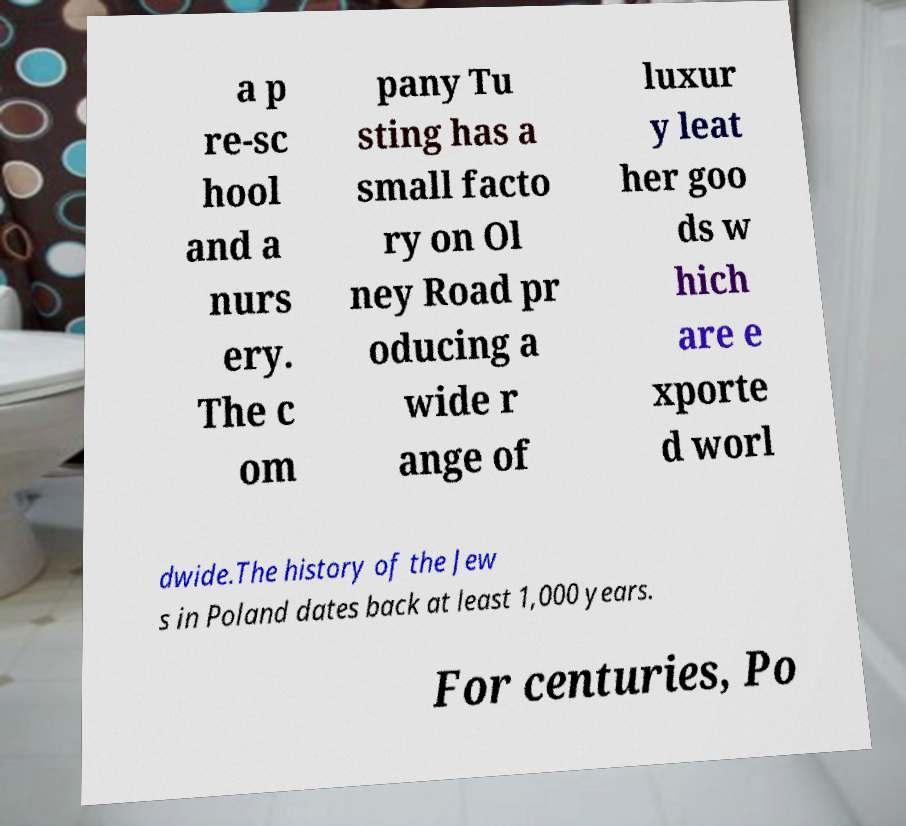For documentation purposes, I need the text within this image transcribed. Could you provide that? a p re-sc hool and a nurs ery. The c om pany Tu sting has a small facto ry on Ol ney Road pr oducing a wide r ange of luxur y leat her goo ds w hich are e xporte d worl dwide.The history of the Jew s in Poland dates back at least 1,000 years. For centuries, Po 